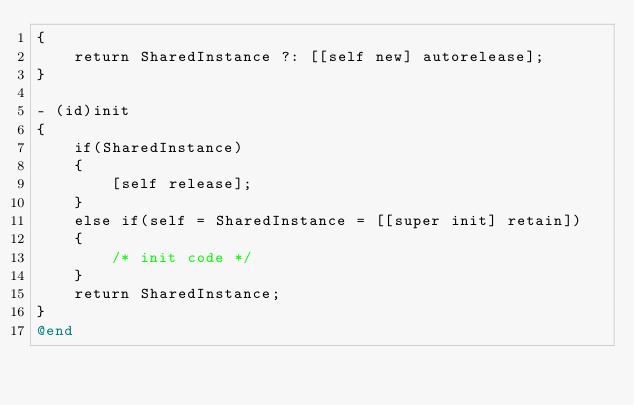<code> <loc_0><loc_0><loc_500><loc_500><_ObjectiveC_>{
	return SharedInstance ?: [[self new] autorelease];
}

- (id)init
{
	if(SharedInstance)
	{
		[self release];
	}
	else if(self = SharedInstance = [[super init] retain])
	{
		/* init code */
	}
	return SharedInstance;
}
@end
</code> 